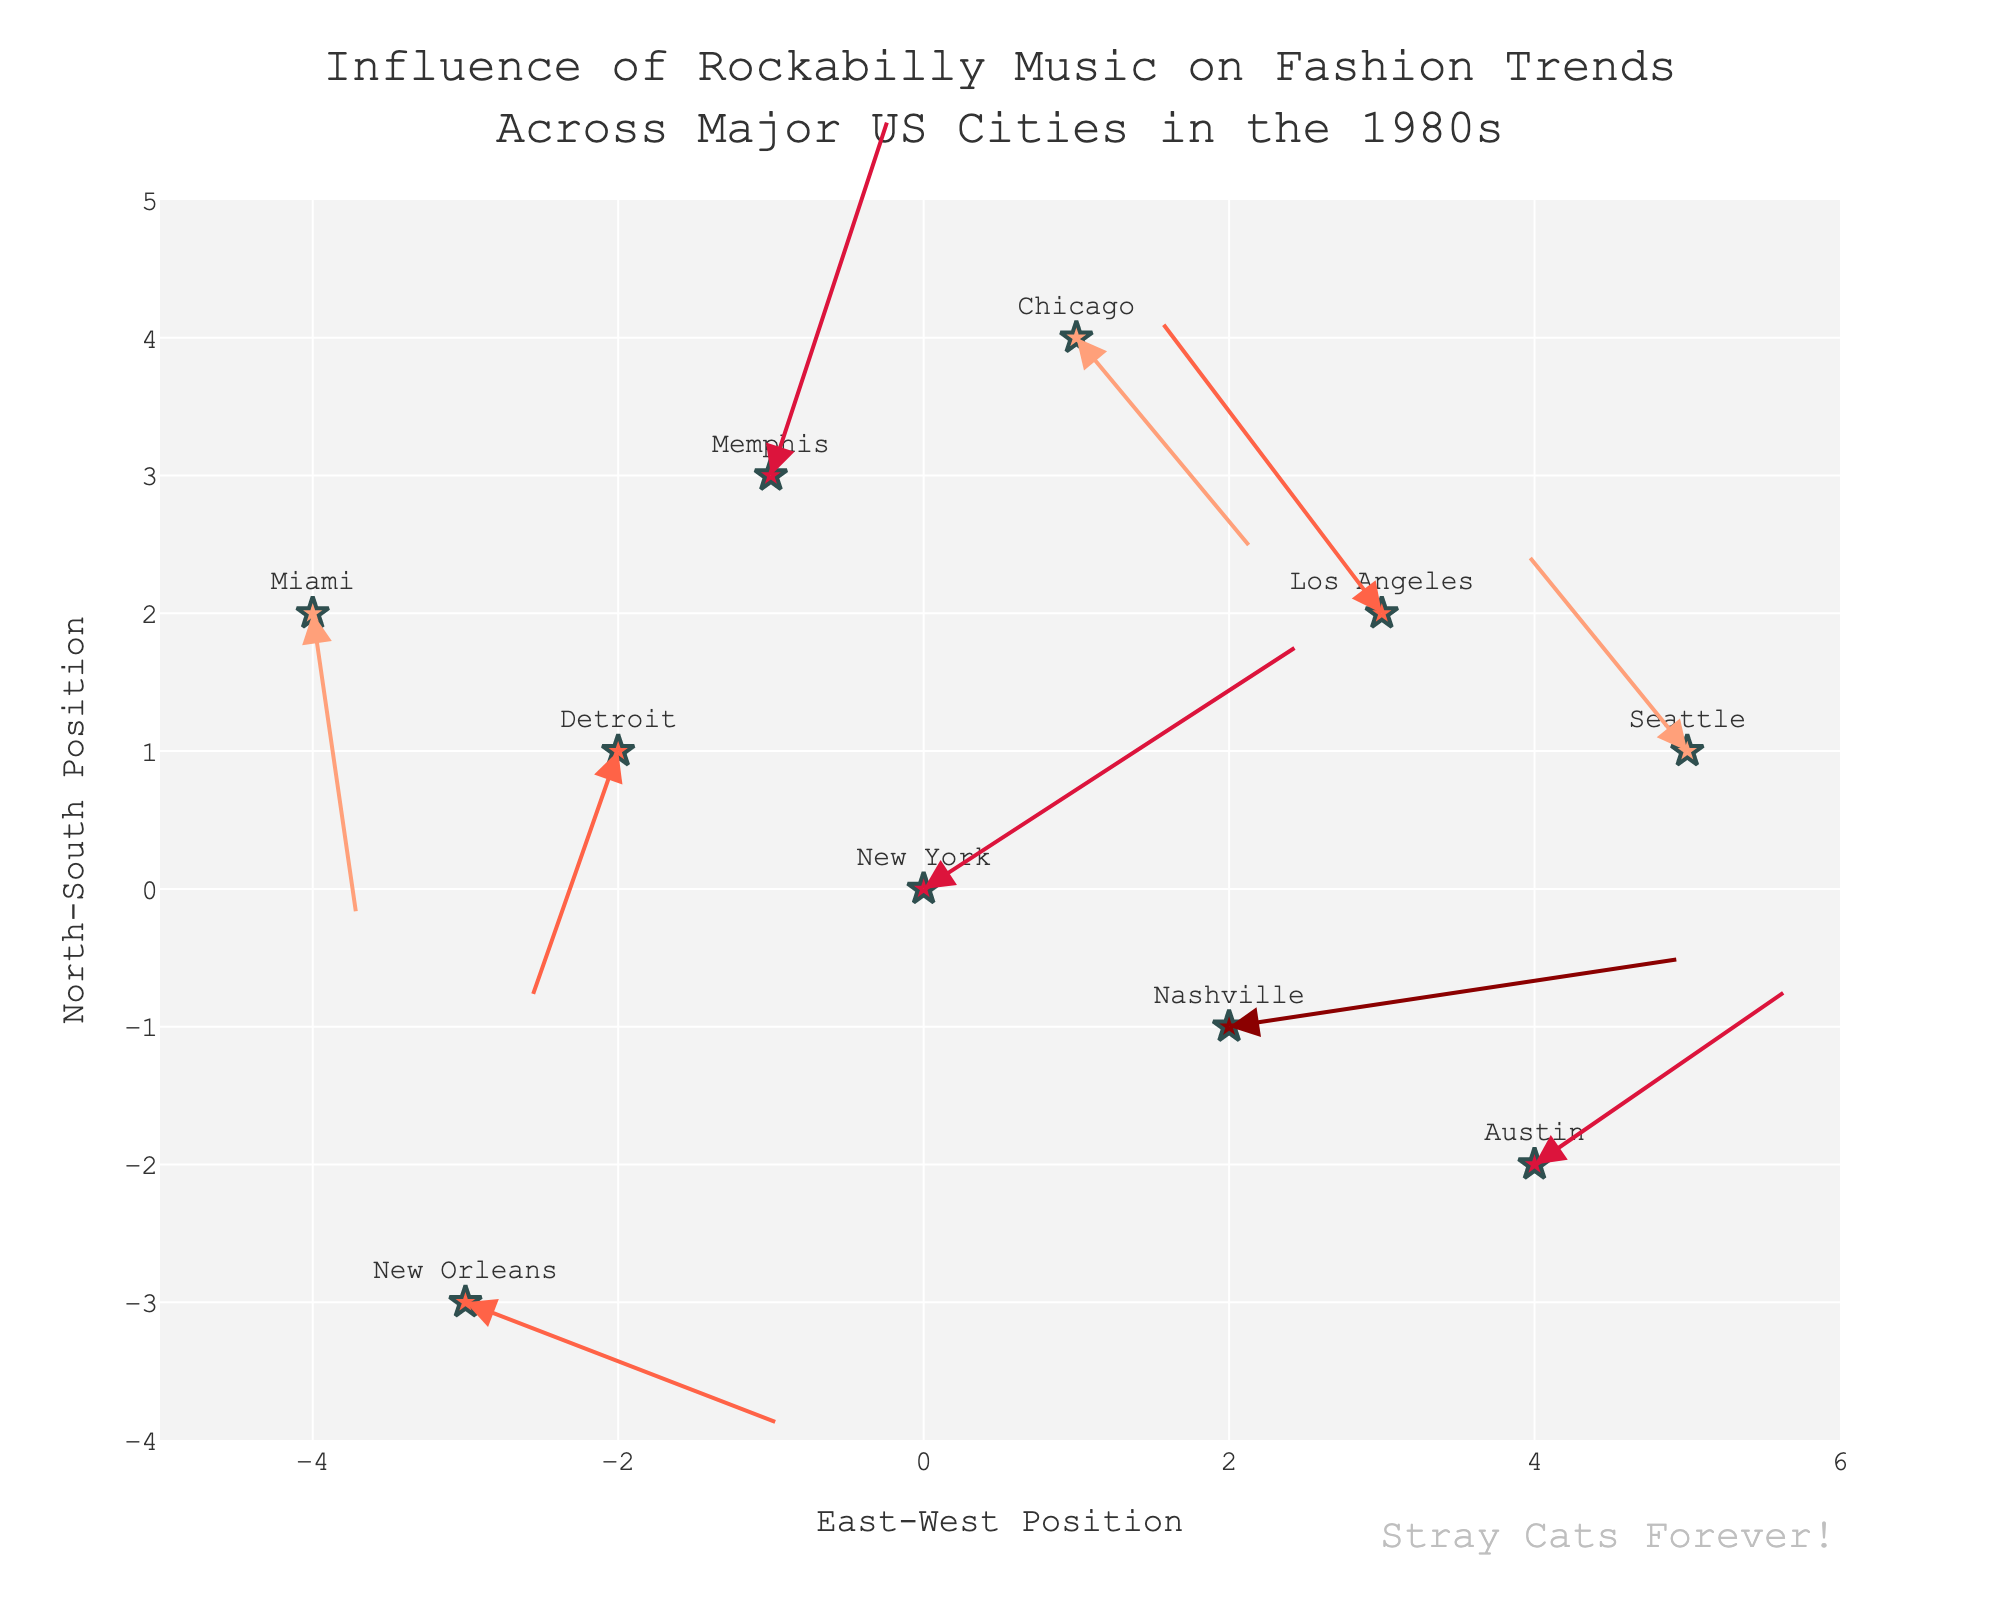How many cities are depicted in the figure? The figure has various markers, each representing a city influenced by rockabilly music. Counting these markers provides the number.
Answer: 10 Which city shows the highest influence of rockabilly music? Cities are marked with different color intensities representing the influence level. The darkest color represents "Very High" influence. Look for the city labeled "Nashville".
Answer: Nashville What is the general direction of the influence vector for Austin? Locate Austin's marker and observe the arrow starting from it. The arrow's direction shows the influence vector.
Answer: Right-Up (East-North) Which cities have an influence level of 'Medium'? Medium influenced cities are marked with a specific color. Identify New Orleans, Los Angeles, and Detroit based on these markers.
Answer: New Orleans, Los Angeles, and Detroit What is the distance vector (U, V) for Chicago, and where does it point? Find the marker for Chicago and inspect the associated arrow. The arrow's length and direction represent its distance vector (U, V = 1.2, -1.6).
Answer: (1.2, -1.6) Which city shows a westward influence represented by a negative X vector component? Analyzing each vector where the U component is negative points to Los Angeles (-1.5), Detroit (-0.6), and Miami (0.3). However, to ensure west, it's the first two cities whose U component is significantly negative.
Answer: Los Angeles and Detroit Compare the influence on fashion trends in New York and Seattle. Which city showcases a higher vector magnitude? Calculate the magnitude of vectors for both New York (sqrt(2.5^2 + 1.8^2)) and Seattle (sqrt(-1.1^2 + 1.5^2)). New York has a larger magnitude.
Answer: New York Between Memphis and Miami, which city has a higher North-South position? Inspect the Y-coordinate values for both Memphis (3) and Miami (2). The city with the higher Y-coordinate is further north.
Answer: Memphis What is the overall trend direction of influence for cities located in the southern region (negative Y values)? Observe the vectors of cities with negative Y-values like Austin (-2) and Nashville (-1). Summarize their general directions.
Answer: East Which city has the smallest northward influence vector (V value)? Analyze all V values and find the city with the smallest positive value. Miami (-2.3) is not northward, thus check remaining cities and find smallest positive V, which points us to Nashville, with V equal to (0.5).
Answer: Nashville 